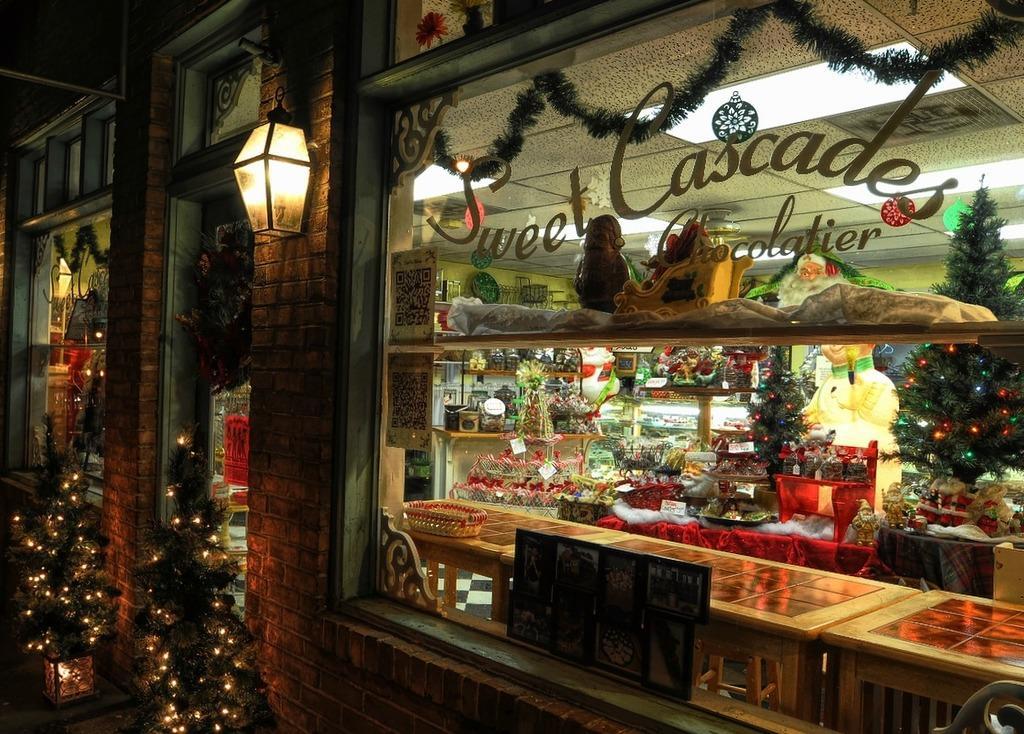Can you describe this image briefly? In this picture we can see a building with glass windows. Inside the building there are decorative plants, ceiling lights and some objects. In front of the building, there are plants with lights. There is a street lamp attached to the wall of a building. On the glass window, it is written something. 